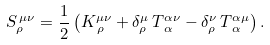Convert formula to latex. <formula><loc_0><loc_0><loc_500><loc_500>S _ { \rho } ^ { \, \mu \nu } = \frac { 1 } { 2 } \left ( K ^ { \mu \nu } _ { \, \rho } + \delta ^ { \mu } _ { \rho } \, T ^ { \alpha \nu } _ { \, \alpha } - \delta ^ { \nu } _ { \rho } \, T ^ { \alpha \mu } _ { \, \alpha } \right ) .</formula> 